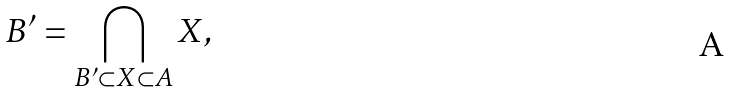<formula> <loc_0><loc_0><loc_500><loc_500>B ^ { \prime } = \bigcap _ { B ^ { \prime } \subset X \subset A } X ,</formula> 